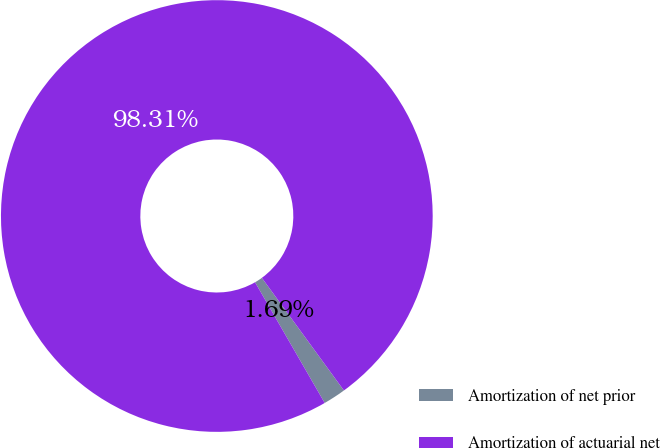Convert chart. <chart><loc_0><loc_0><loc_500><loc_500><pie_chart><fcel>Amortization of net prior<fcel>Amortization of actuarial net<nl><fcel>1.69%<fcel>98.31%<nl></chart> 